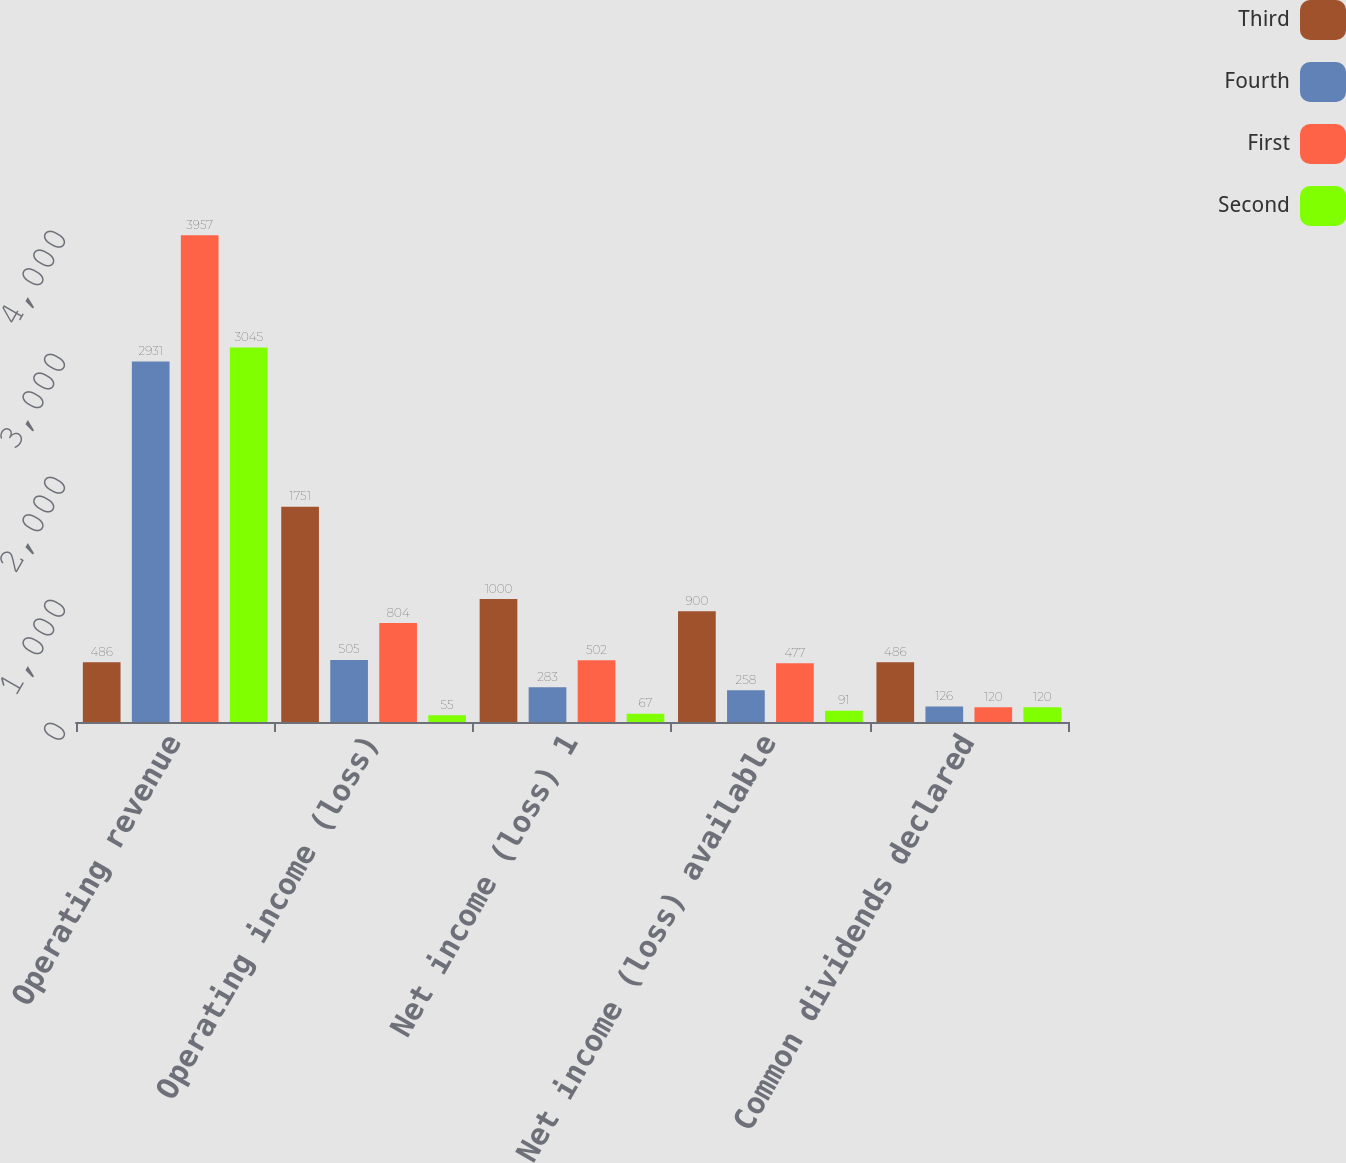Convert chart. <chart><loc_0><loc_0><loc_500><loc_500><stacked_bar_chart><ecel><fcel>Operating revenue<fcel>Operating income (loss)<fcel>Net income (loss) 1<fcel>Net income (loss) available<fcel>Common dividends declared<nl><fcel>Third<fcel>486<fcel>1751<fcel>1000<fcel>900<fcel>486<nl><fcel>Fourth<fcel>2931<fcel>505<fcel>283<fcel>258<fcel>126<nl><fcel>First<fcel>3957<fcel>804<fcel>502<fcel>477<fcel>120<nl><fcel>Second<fcel>3045<fcel>55<fcel>67<fcel>91<fcel>120<nl></chart> 